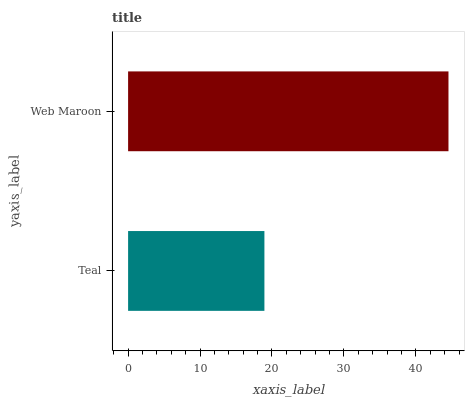Is Teal the minimum?
Answer yes or no. Yes. Is Web Maroon the maximum?
Answer yes or no. Yes. Is Web Maroon the minimum?
Answer yes or no. No. Is Web Maroon greater than Teal?
Answer yes or no. Yes. Is Teal less than Web Maroon?
Answer yes or no. Yes. Is Teal greater than Web Maroon?
Answer yes or no. No. Is Web Maroon less than Teal?
Answer yes or no. No. Is Web Maroon the high median?
Answer yes or no. Yes. Is Teal the low median?
Answer yes or no. Yes. Is Teal the high median?
Answer yes or no. No. Is Web Maroon the low median?
Answer yes or no. No. 